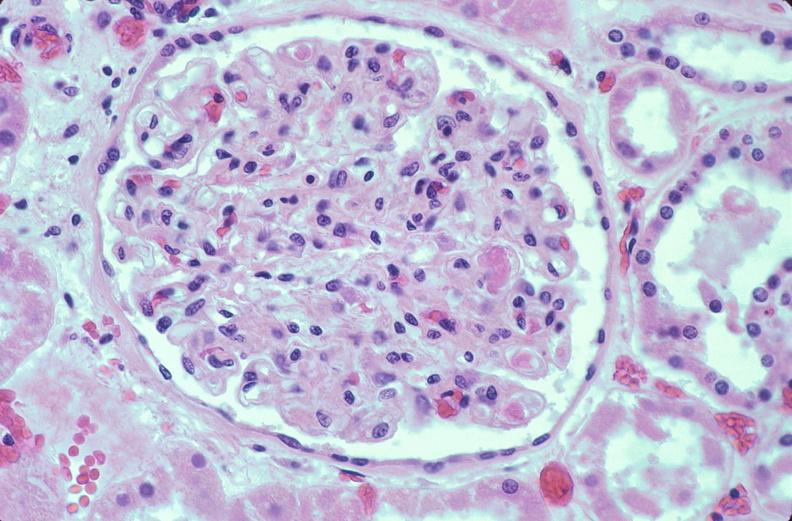does this image show kidney, microthrombi, disseminated intravascular coagulation?
Answer the question using a single word or phrase. Yes 